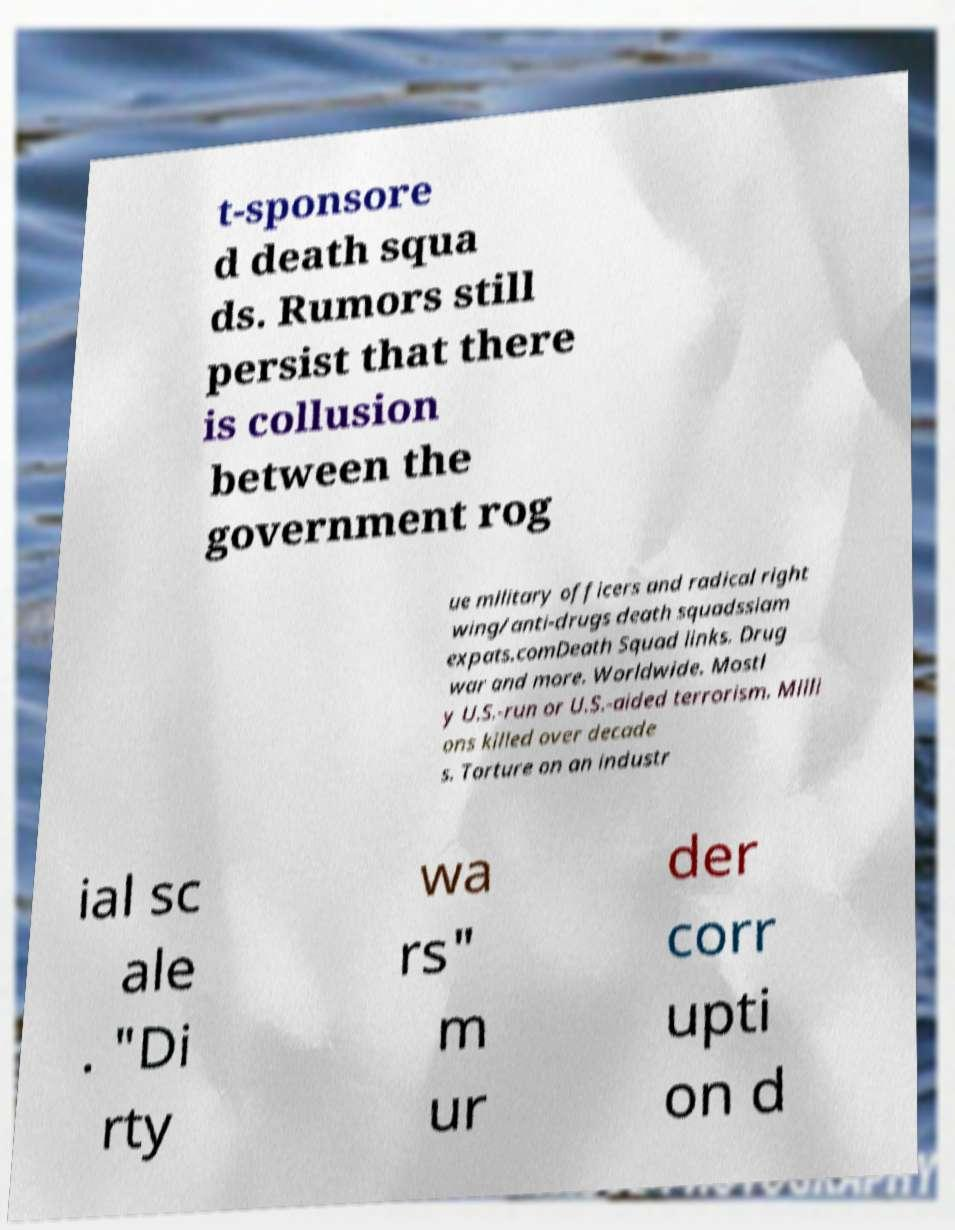Please read and relay the text visible in this image. What does it say? t-sponsore d death squa ds. Rumors still persist that there is collusion between the government rog ue military officers and radical right wing/anti-drugs death squadssiam expats.comDeath Squad links. Drug war and more. Worldwide. Mostl y U.S.-run or U.S.-aided terrorism. Milli ons killed over decade s. Torture on an industr ial sc ale . "Di rty wa rs" m ur der corr upti on d 